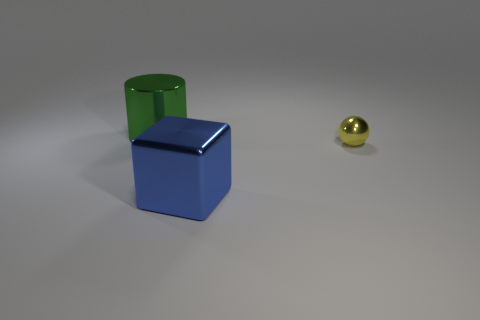Add 1 purple cylinders. How many objects exist? 4 Subtract all balls. How many objects are left? 2 Subtract all large red blocks. Subtract all shiny cylinders. How many objects are left? 2 Add 2 big green metallic things. How many big green metallic things are left? 3 Add 3 large blue objects. How many large blue objects exist? 4 Subtract 1 blue cubes. How many objects are left? 2 Subtract 1 cylinders. How many cylinders are left? 0 